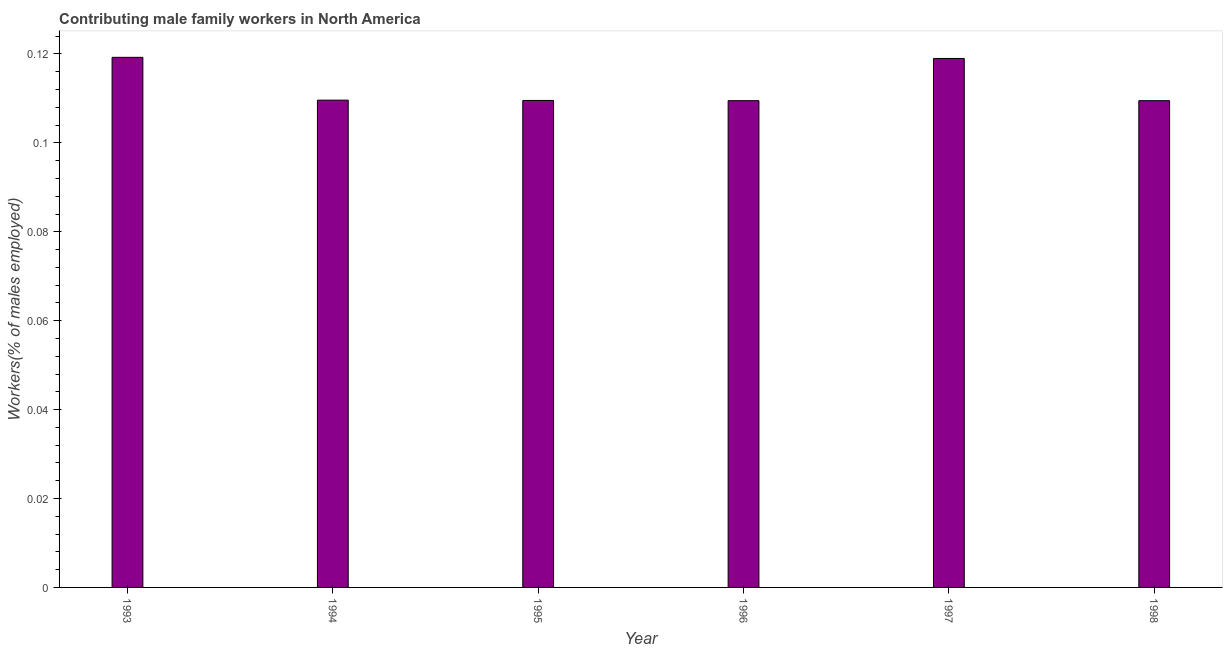What is the title of the graph?
Your response must be concise. Contributing male family workers in North America. What is the label or title of the Y-axis?
Ensure brevity in your answer.  Workers(% of males employed). What is the contributing male family workers in 1996?
Your answer should be compact. 0.11. Across all years, what is the maximum contributing male family workers?
Your answer should be very brief. 0.12. Across all years, what is the minimum contributing male family workers?
Your answer should be very brief. 0.11. What is the sum of the contributing male family workers?
Provide a succinct answer. 0.68. What is the difference between the contributing male family workers in 1994 and 1996?
Provide a short and direct response. 0. What is the average contributing male family workers per year?
Your response must be concise. 0.11. What is the median contributing male family workers?
Give a very brief answer. 0.11. In how many years, is the contributing male family workers greater than 0.008 %?
Your answer should be compact. 6. Do a majority of the years between 1995 and 1997 (inclusive) have contributing male family workers greater than 0.088 %?
Your answer should be compact. Yes. What is the ratio of the contributing male family workers in 1993 to that in 1998?
Provide a succinct answer. 1.09. Is the difference between the contributing male family workers in 1994 and 1996 greater than the difference between any two years?
Your response must be concise. No. Is the sum of the contributing male family workers in 1994 and 1996 greater than the maximum contributing male family workers across all years?
Offer a terse response. Yes. What is the difference between the highest and the lowest contributing male family workers?
Provide a succinct answer. 0.01. How many bars are there?
Your answer should be compact. 6. How many years are there in the graph?
Offer a very short reply. 6. What is the difference between two consecutive major ticks on the Y-axis?
Your answer should be very brief. 0.02. Are the values on the major ticks of Y-axis written in scientific E-notation?
Give a very brief answer. No. What is the Workers(% of males employed) of 1993?
Make the answer very short. 0.12. What is the Workers(% of males employed) in 1994?
Make the answer very short. 0.11. What is the Workers(% of males employed) in 1995?
Offer a terse response. 0.11. What is the Workers(% of males employed) in 1996?
Give a very brief answer. 0.11. What is the Workers(% of males employed) of 1997?
Keep it short and to the point. 0.12. What is the Workers(% of males employed) in 1998?
Offer a terse response. 0.11. What is the difference between the Workers(% of males employed) in 1993 and 1994?
Provide a succinct answer. 0.01. What is the difference between the Workers(% of males employed) in 1993 and 1995?
Your response must be concise. 0.01. What is the difference between the Workers(% of males employed) in 1993 and 1996?
Your answer should be very brief. 0.01. What is the difference between the Workers(% of males employed) in 1993 and 1997?
Give a very brief answer. 0. What is the difference between the Workers(% of males employed) in 1993 and 1998?
Ensure brevity in your answer.  0.01. What is the difference between the Workers(% of males employed) in 1994 and 1995?
Provide a short and direct response. 7e-5. What is the difference between the Workers(% of males employed) in 1994 and 1996?
Your answer should be very brief. 0. What is the difference between the Workers(% of males employed) in 1994 and 1997?
Offer a very short reply. -0.01. What is the difference between the Workers(% of males employed) in 1994 and 1998?
Give a very brief answer. 0. What is the difference between the Workers(% of males employed) in 1995 and 1996?
Make the answer very short. 5e-5. What is the difference between the Workers(% of males employed) in 1995 and 1997?
Provide a short and direct response. -0.01. What is the difference between the Workers(% of males employed) in 1995 and 1998?
Ensure brevity in your answer.  5e-5. What is the difference between the Workers(% of males employed) in 1996 and 1997?
Keep it short and to the point. -0.01. What is the difference between the Workers(% of males employed) in 1997 and 1998?
Make the answer very short. 0.01. What is the ratio of the Workers(% of males employed) in 1993 to that in 1994?
Your answer should be compact. 1.09. What is the ratio of the Workers(% of males employed) in 1993 to that in 1995?
Your response must be concise. 1.09. What is the ratio of the Workers(% of males employed) in 1993 to that in 1996?
Provide a short and direct response. 1.09. What is the ratio of the Workers(% of males employed) in 1993 to that in 1998?
Make the answer very short. 1.09. What is the ratio of the Workers(% of males employed) in 1994 to that in 1996?
Ensure brevity in your answer.  1. What is the ratio of the Workers(% of males employed) in 1994 to that in 1997?
Make the answer very short. 0.92. What is the ratio of the Workers(% of males employed) in 1995 to that in 1997?
Your answer should be compact. 0.92. What is the ratio of the Workers(% of males employed) in 1996 to that in 1997?
Offer a very short reply. 0.92. What is the ratio of the Workers(% of males employed) in 1997 to that in 1998?
Your answer should be compact. 1.09. 